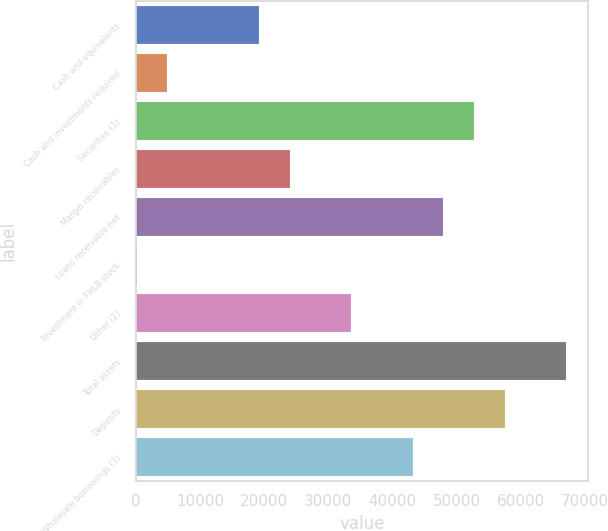Convert chart to OTSL. <chart><loc_0><loc_0><loc_500><loc_500><bar_chart><fcel>Cash and equivalents<fcel>Cash and investments required<fcel>Securities (1)<fcel>Margin receivables<fcel>Loans receivable net<fcel>Investment in FHLB stock<fcel>Other (2)<fcel>Total assets<fcel>Deposits<fcel>Wholesale borrowings (3)<nl><fcel>19260.3<fcel>4920.23<fcel>52720.5<fcel>24040.3<fcel>47940.5<fcel>140.2<fcel>33600.4<fcel>67060.6<fcel>57500.6<fcel>43160.5<nl></chart> 